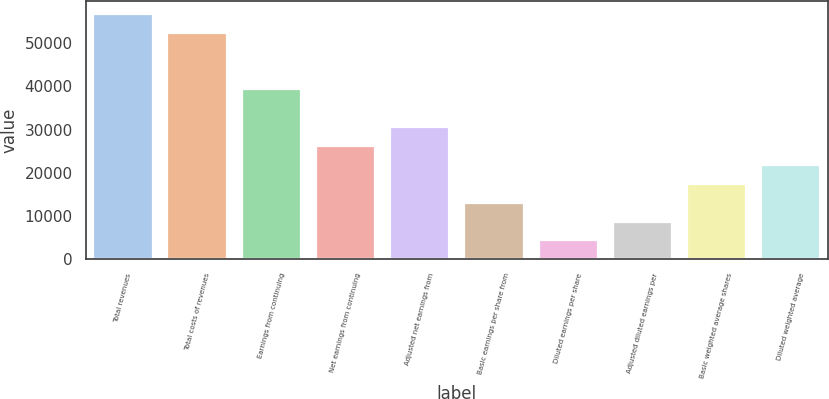Convert chart. <chart><loc_0><loc_0><loc_500><loc_500><bar_chart><fcel>Total revenues<fcel>Total costs of revenues<fcel>Earnings from continuing<fcel>Net earnings from continuing<fcel>Adjusted net earnings from<fcel>Basic earnings per share from<fcel>Diluted earnings per share<fcel>Adjusted diluted earnings per<fcel>Basic weighted average shares<fcel>Diluted weighted average<nl><fcel>56770.3<fcel>52403.6<fcel>39303.2<fcel>26202.8<fcel>30569.6<fcel>13102.5<fcel>4368.87<fcel>8735.66<fcel>17469.2<fcel>21836<nl></chart> 